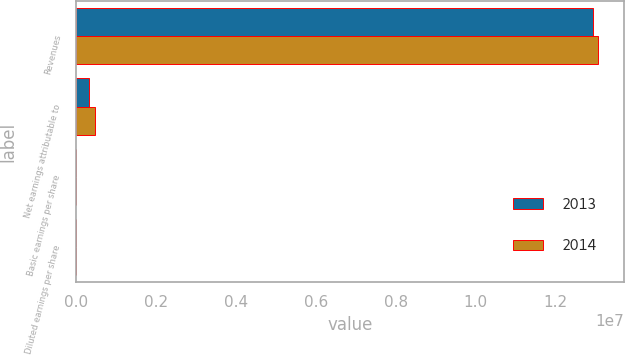<chart> <loc_0><loc_0><loc_500><loc_500><stacked_bar_chart><ecel><fcel>Revenues<fcel>Net earnings attributable to<fcel>Basic earnings per share<fcel>Diluted earnings per share<nl><fcel>2013<fcel>1.29448e+07<fcel>335658<fcel>2.57<fcel>2.54<nl><fcel>2014<fcel>1.30648e+07<fcel>488434<fcel>3.78<fcel>3.73<nl></chart> 